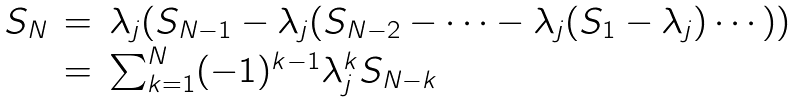<formula> <loc_0><loc_0><loc_500><loc_500>\begin{array} { r c l } S _ { N } & = & \lambda _ { j } ( S _ { N - 1 } - \lambda _ { j } ( S _ { N - 2 } - \cdots - \lambda _ { j } ( S _ { 1 } - \lambda _ { j } ) \cdots ) ) \\ & = & \sum _ { k = 1 } ^ { N } ( - 1 ) ^ { k - 1 } \lambda _ { j } ^ { k } S _ { N - k } \\ \end{array}</formula> 